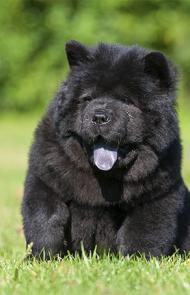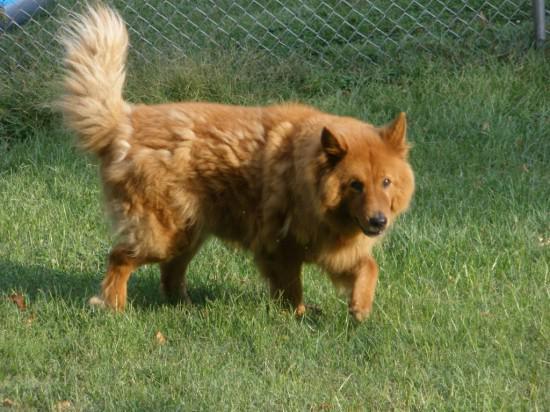The first image is the image on the left, the second image is the image on the right. Examine the images to the left and right. Is the description "There are two dogs" accurate? Answer yes or no. Yes. The first image is the image on the left, the second image is the image on the right. Assess this claim about the two images: "Two young chows are side-by-side in one of the images.". Correct or not? Answer yes or no. No. 